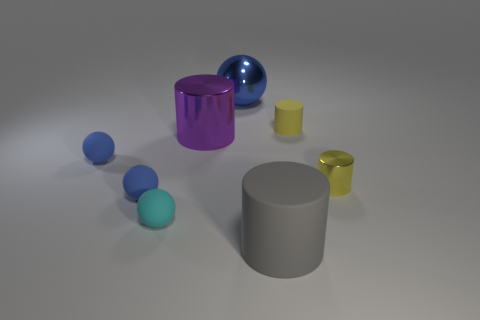Is there a brown thing made of the same material as the big gray cylinder?
Keep it short and to the point. No. What number of things are either yellow shiny objects or large yellow matte cylinders?
Make the answer very short. 1. Are the cyan sphere and the cylinder that is left of the gray matte thing made of the same material?
Your response must be concise. No. There is a metal thing on the right side of the metal sphere; what is its size?
Your answer should be very brief. Small. Is the number of large spheres less than the number of blue objects?
Give a very brief answer. Yes. Are there any big metal cylinders of the same color as the big matte thing?
Provide a succinct answer. No. The tiny thing that is on the right side of the cyan thing and in front of the big purple shiny cylinder has what shape?
Offer a terse response. Cylinder. What is the shape of the blue rubber thing that is behind the blue matte thing that is in front of the small metal object?
Provide a succinct answer. Sphere. Do the gray object and the yellow metallic thing have the same shape?
Offer a very short reply. Yes. What material is the small thing that is the same color as the small shiny cylinder?
Give a very brief answer. Rubber. 